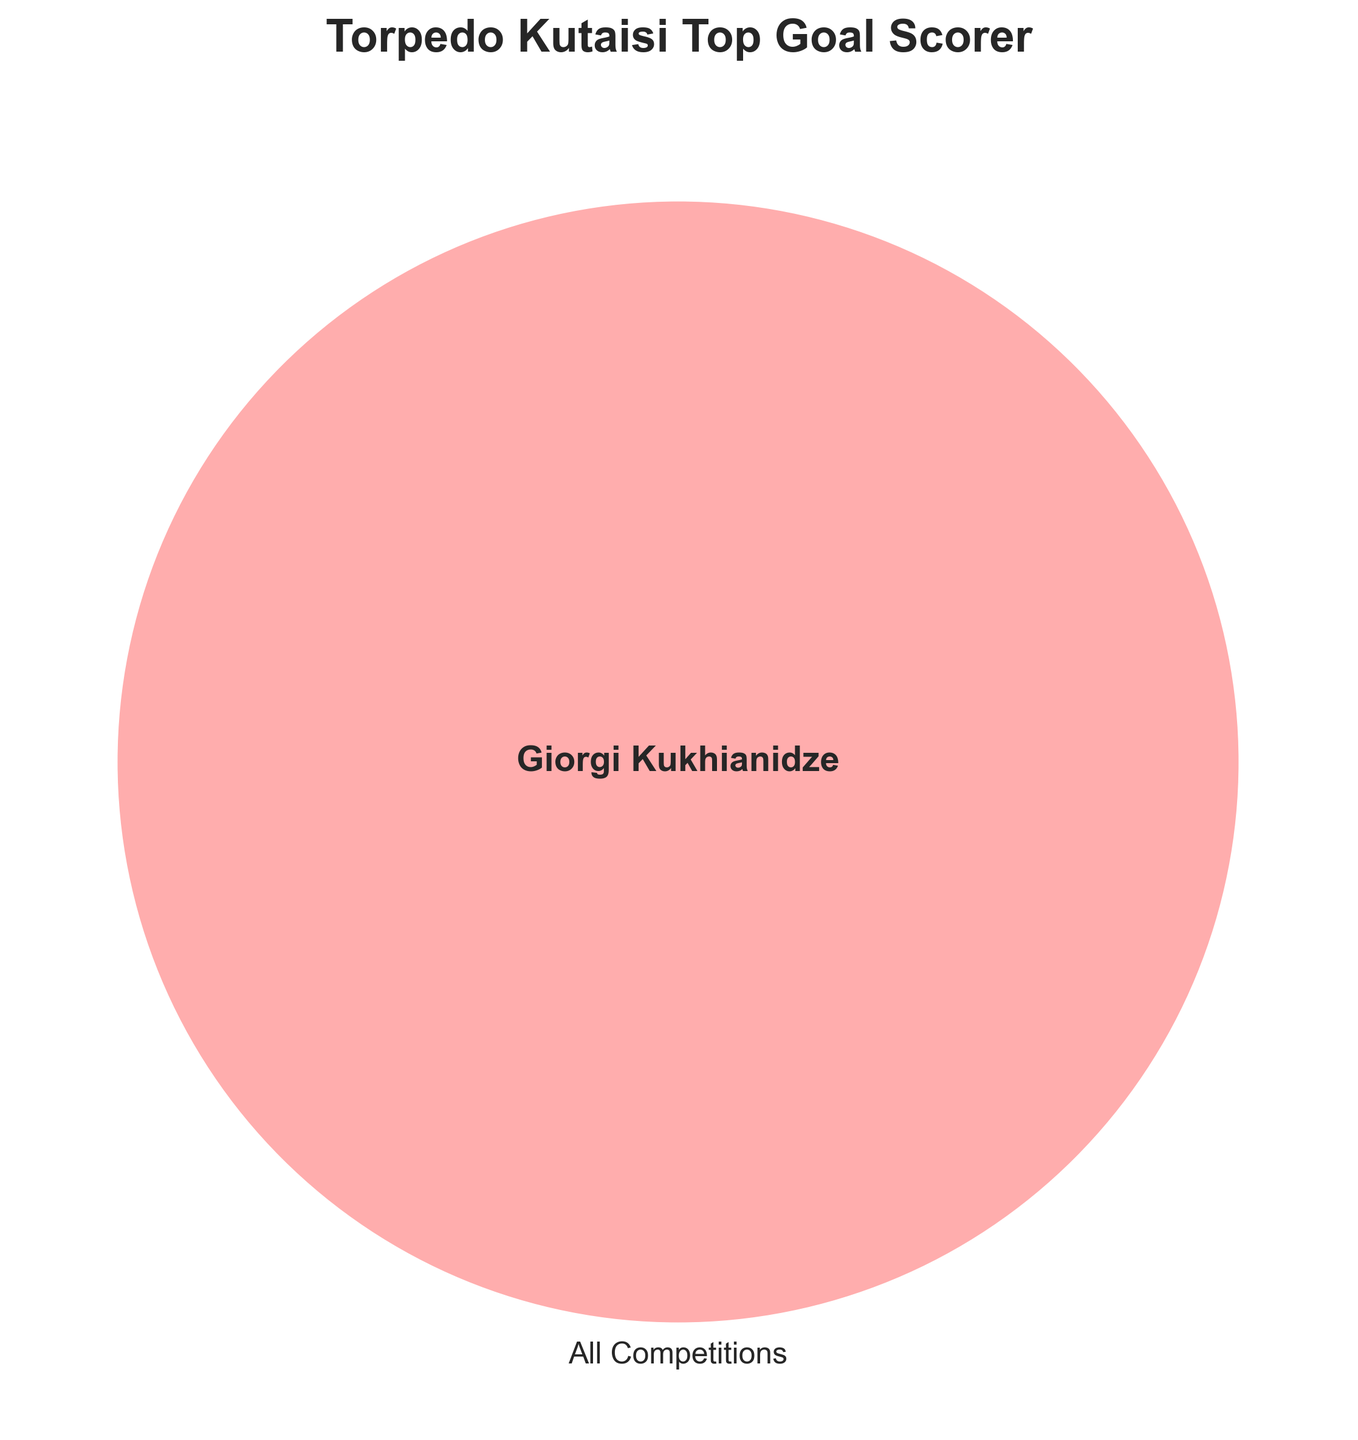What's the title of the figure? The figure title is positioned at the top center of the diagram and reads “Torpedo Kutaisi Top Goal Scorer.”
Answer: Torpedo Kutaisi Top Goal Scorer What player is named in the Venn Diagram? The name in the center of the Venn diagram is added as a text overlay and reads "Giorgi Kukhianidze."
Answer: Giorgi Kukhianidze Which competitions are compared in the Venn Diagram? The Venn diagram uses one labeled circle, representing "All Competitions," indicated by the label on the left circle of the Venn Diagram.
Answer: All Competitions How many circles are used in the Venn Diagram? The diagram contains three partially overlapping circles, but only one circle ("All Competitions") is labeled.
Answer: Three What color is the "All Competitions" circle? The color of the "All Competitions" circle is a shade of red, distinguishable by visual inspection.
Answer: Red Does the diagram show any player overlapping multiple competitions? The Venn diagram does not show overlaps between different competition categories; only "All Competitions" is labeled with one player, Giorgi Kukhianidze.
Answer: No What font style is used for the player’s name in the center? The player’s name is displayed in a bold font style, which is visually emphasized in the center of the diagram.
Answer: Bold Are the subset sizes shown in the diagram? The subset sizes are not visible in the diagram, as deemed unnecessary for this single player designation.
Answer: No What's the diagram's background style? The diagram uses a styled background, resembling a white grid pattern, based on the overall visual texture.
Answer: White grid Does the diagram show individual goal counts? The diagram does not display individual goal counts; it only illustrates the top goal scorer within the "All Competitions" category.
Answer: No 